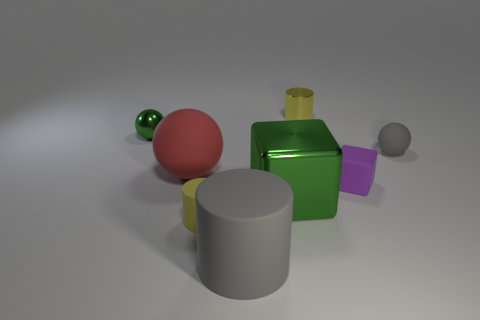Add 2 tiny yellow shiny cylinders. How many objects exist? 10 Subtract all cylinders. How many objects are left? 5 Subtract all red balls. Subtract all big metal objects. How many objects are left? 6 Add 5 large green metal things. How many large green metal things are left? 6 Add 3 large metallic blocks. How many large metallic blocks exist? 4 Subtract 0 brown cylinders. How many objects are left? 8 